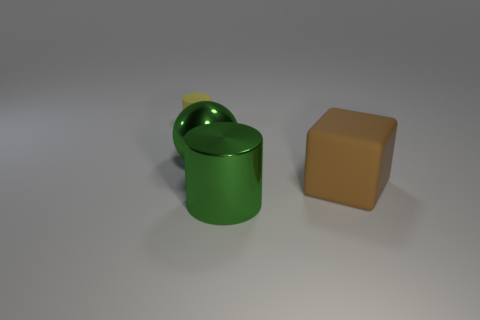Is the large sphere the same color as the big shiny cylinder?
Keep it short and to the point. Yes. Are there any things in front of the cylinder that is right of the small yellow matte cylinder?
Make the answer very short. No. Are any small blocks visible?
Make the answer very short. No. What number of metallic cylinders have the same size as the metallic ball?
Keep it short and to the point. 1. How many large things are to the right of the shiny sphere and behind the green cylinder?
Provide a short and direct response. 1. Does the rubber object on the left side of the brown cube have the same size as the cube?
Give a very brief answer. No. Is there a large object of the same color as the shiny sphere?
Provide a succinct answer. Yes. What size is the green cylinder that is made of the same material as the big ball?
Offer a terse response. Large. Are there more brown blocks in front of the big brown rubber block than large brown matte objects that are in front of the big green metal cylinder?
Offer a very short reply. No. What number of other things are the same material as the small yellow object?
Your answer should be very brief. 1. 